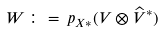<formula> <loc_0><loc_0><loc_500><loc_500>W \, \colon = \, p _ { X * } ( V \otimes \widehat { V } ^ { * } )</formula> 